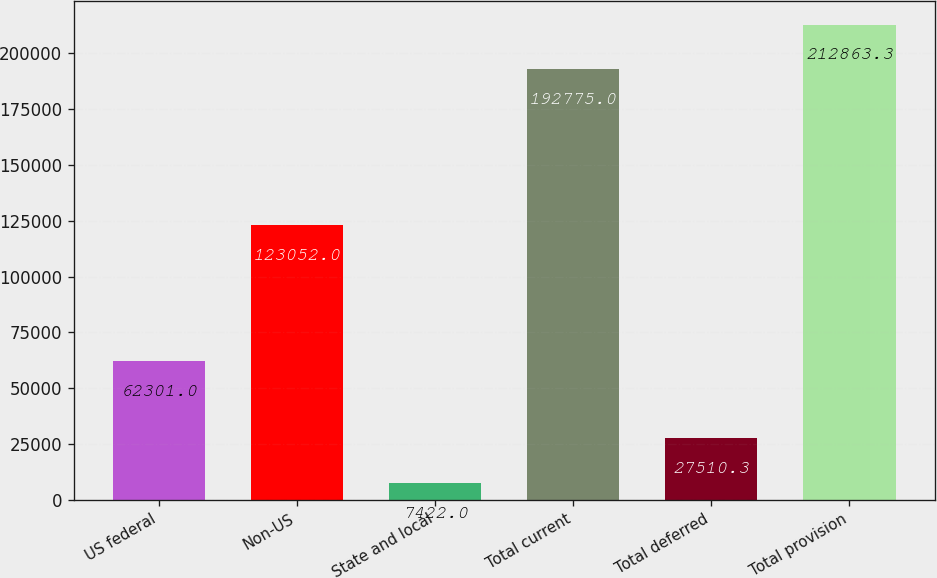Convert chart. <chart><loc_0><loc_0><loc_500><loc_500><bar_chart><fcel>US federal<fcel>Non-US<fcel>State and local<fcel>Total current<fcel>Total deferred<fcel>Total provision<nl><fcel>62301<fcel>123052<fcel>7422<fcel>192775<fcel>27510.3<fcel>212863<nl></chart> 